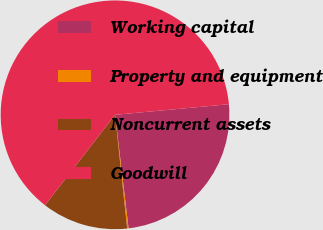Convert chart. <chart><loc_0><loc_0><loc_500><loc_500><pie_chart><fcel>Working capital<fcel>Property and equipment<fcel>Noncurrent assets<fcel>Goodwill<nl><fcel>24.59%<fcel>0.2%<fcel>12.18%<fcel>63.03%<nl></chart> 